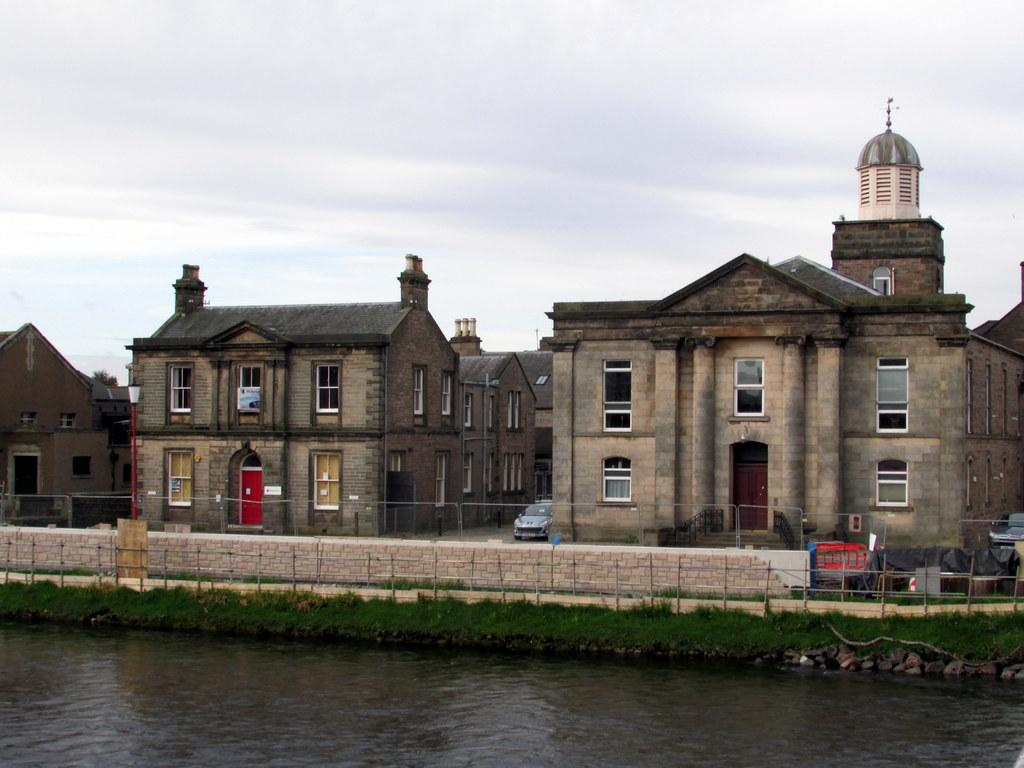What is in the foreground of the image? There is water, grass, and a railing in the foreground of the image. What can be seen in the background of the image? There are buildings, a vehicle, and the sky visible in the background of the image. What is the weather like in the image? The presence of a cloud in the sky suggests that it might be partly cloudy. What type of surface is visible in the foreground? The grass in the foreground suggests that the surface is likely a grassy area. Where is the zoo located in the image? There is no zoo present in the image. What word is written on the railing in the image? There is no word written on the railing in the image. 